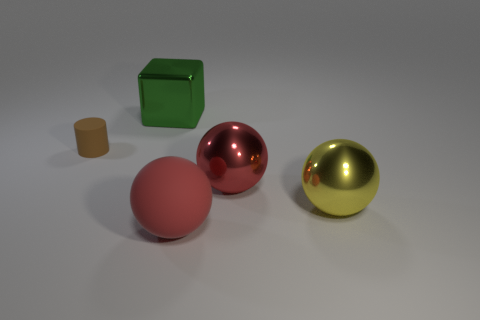How would you use these objects in a teaching lesson? These objects could be used to teach various concepts: color identification, geometric shapes, the difference between matte and reflective surfaces, and basic principles of light and shadow in photography or art. 